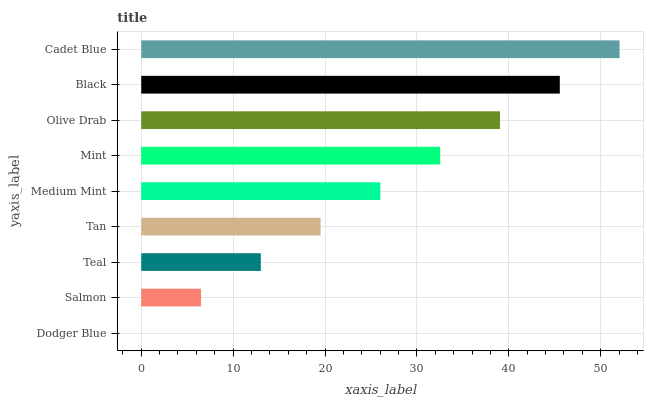Is Dodger Blue the minimum?
Answer yes or no. Yes. Is Cadet Blue the maximum?
Answer yes or no. Yes. Is Salmon the minimum?
Answer yes or no. No. Is Salmon the maximum?
Answer yes or no. No. Is Salmon greater than Dodger Blue?
Answer yes or no. Yes. Is Dodger Blue less than Salmon?
Answer yes or no. Yes. Is Dodger Blue greater than Salmon?
Answer yes or no. No. Is Salmon less than Dodger Blue?
Answer yes or no. No. Is Medium Mint the high median?
Answer yes or no. Yes. Is Medium Mint the low median?
Answer yes or no. Yes. Is Black the high median?
Answer yes or no. No. Is Salmon the low median?
Answer yes or no. No. 